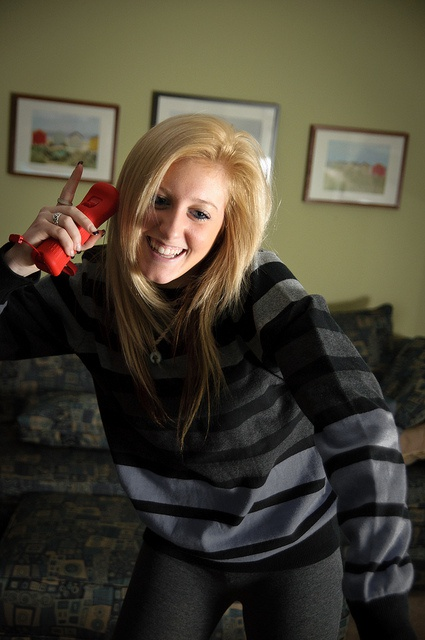Describe the objects in this image and their specific colors. I can see people in black, gray, maroon, and tan tones, couch in black and gray tones, and remote in black, maroon, brown, and red tones in this image. 